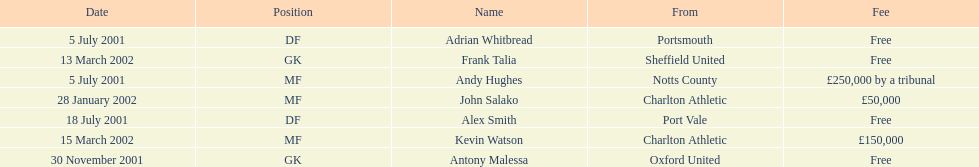Are there at least 2 nationalities on the chart? Yes. 